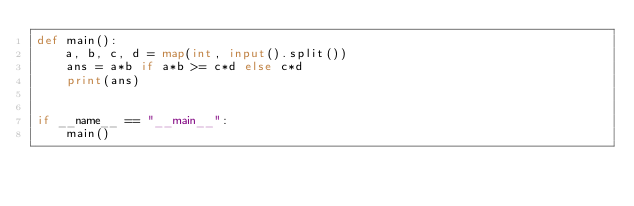Convert code to text. <code><loc_0><loc_0><loc_500><loc_500><_Python_>def main():
    a, b, c, d = map(int, input().split())
    ans = a*b if a*b >= c*d else c*d
    print(ans)
    

if __name__ == "__main__":
    main()</code> 